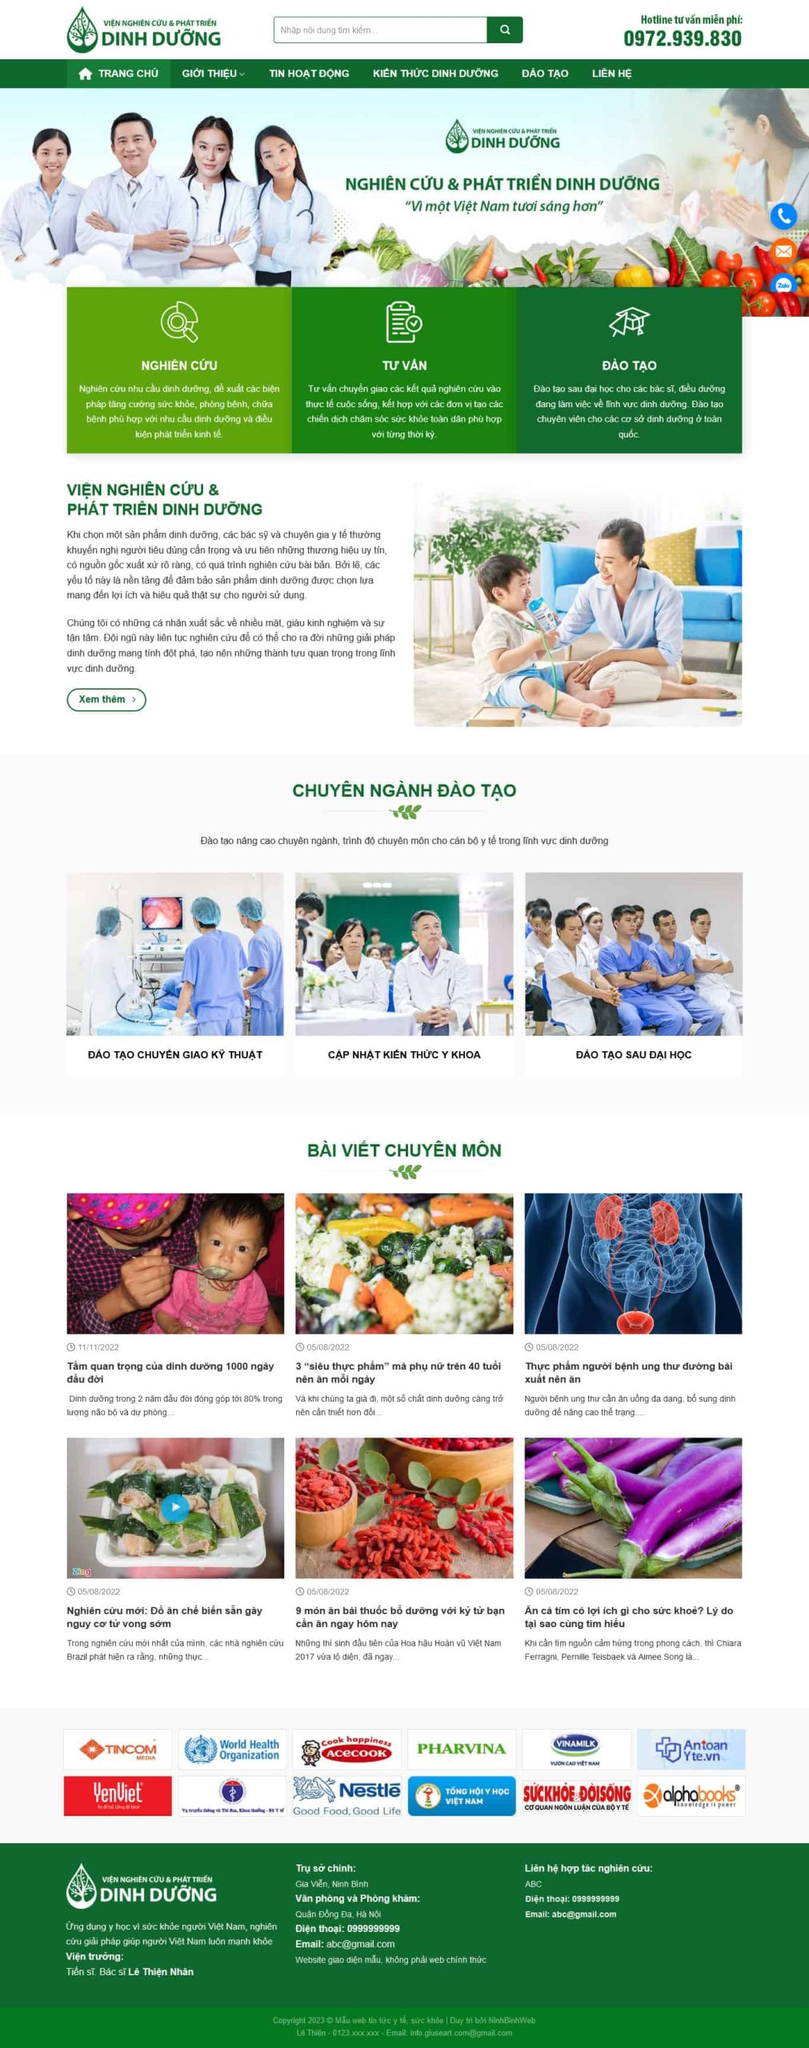Liệt kê 5 ngành nghề, lĩnh vực phù hợp với website này, phân cách các màu sắc bằng dấu phẩy. Chỉ trả về kết quả, phân cách bằng dấy phẩy
 Y tế, chăm sóc sức khỏe, dinh dưỡng, giáo dục, nghiên cứu khoa học 